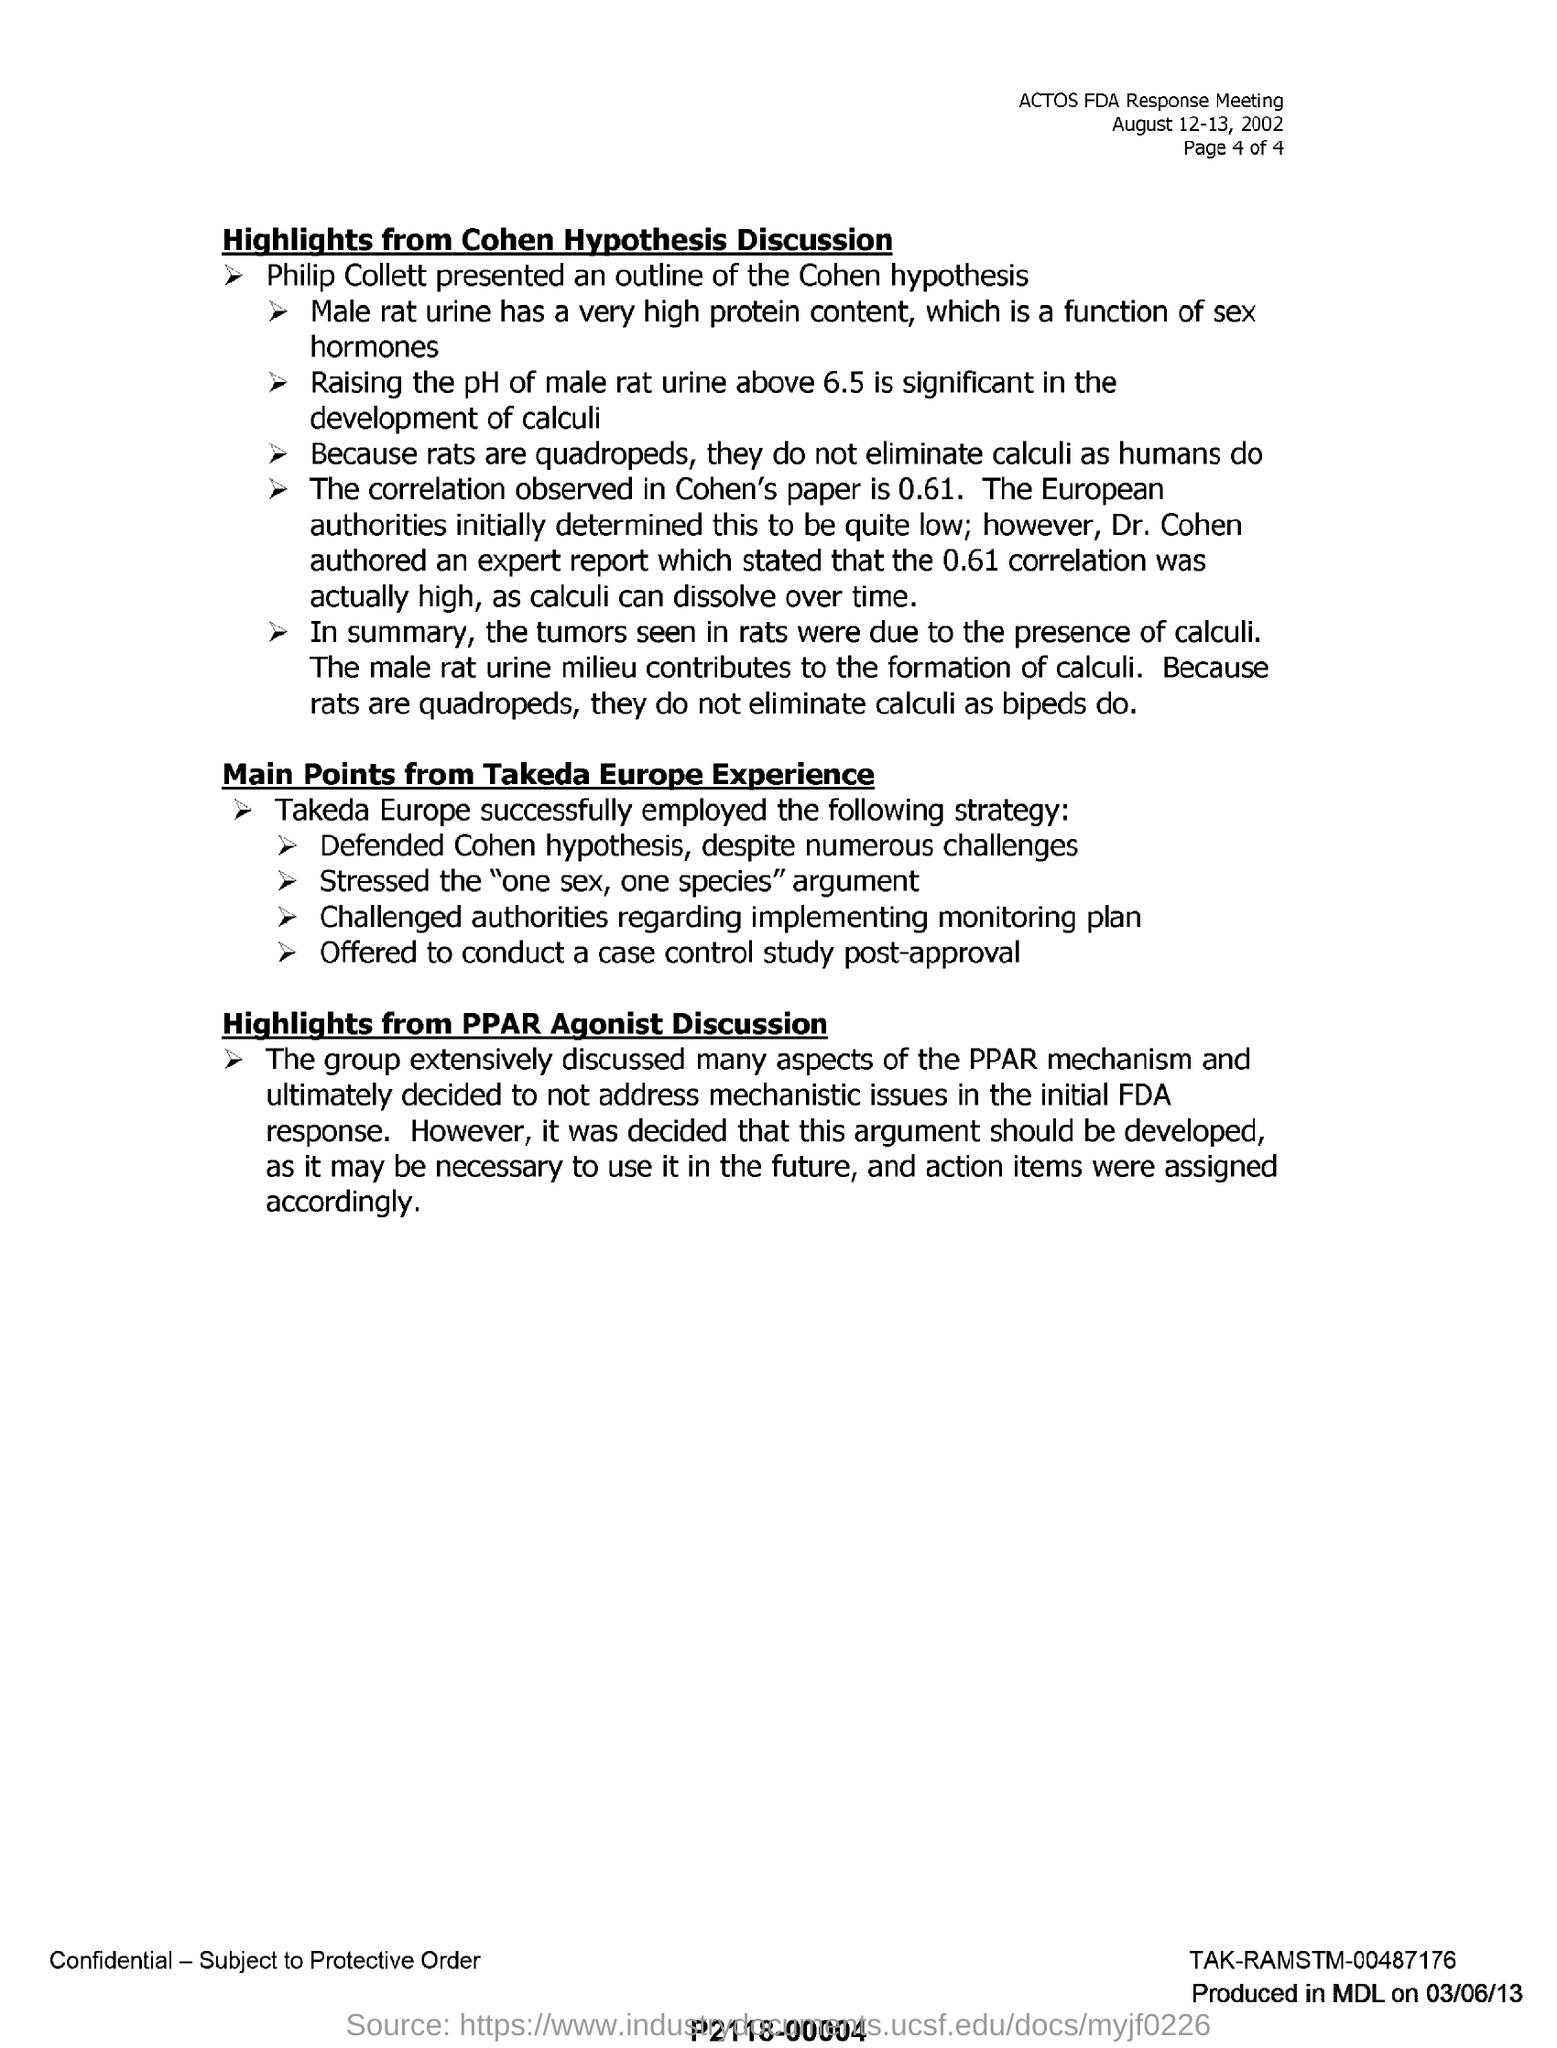Point out several critical features in this image. Calculi, the solid formations that can develop in the urinary system, are not eliminated by rats in the same way that humans do because rats are quadrupeds. Takeda Europe has challenged the authorities regarding the implementation of a monitoring plan. The significant development in the history of calculi involves raising the pH of male rat urine above 6.5, which has been shown to trigger the formation of kidney stones. This discovery has revolutionized the field of urology and has provided new therapeutic options for patients with kidney stones. Philip Collett presented an outline of the Cohen hypothesis. The correlation observed in Cohen's paper is 0.61. 